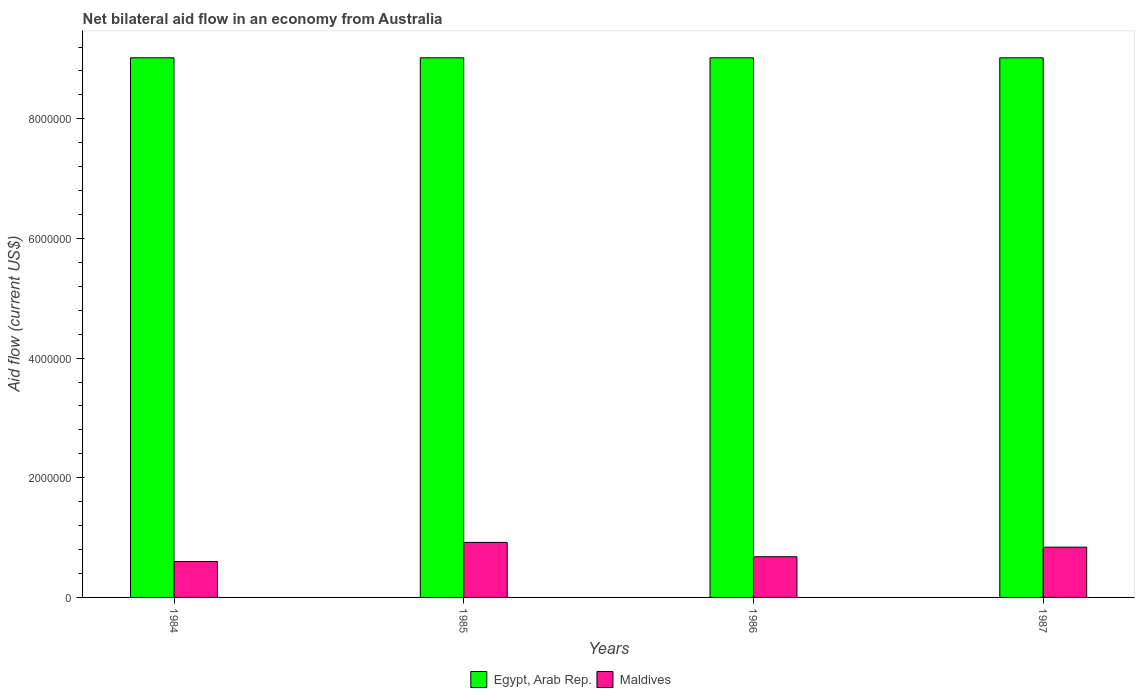How many different coloured bars are there?
Offer a terse response. 2. Are the number of bars per tick equal to the number of legend labels?
Offer a terse response. Yes. How many bars are there on the 4th tick from the right?
Offer a terse response. 2. What is the label of the 4th group of bars from the left?
Provide a short and direct response. 1987. In how many cases, is the number of bars for a given year not equal to the number of legend labels?
Make the answer very short. 0. What is the net bilateral aid flow in Maldives in 1985?
Provide a short and direct response. 9.20e+05. Across all years, what is the maximum net bilateral aid flow in Maldives?
Give a very brief answer. 9.20e+05. What is the total net bilateral aid flow in Maldives in the graph?
Your answer should be very brief. 3.04e+06. What is the difference between the net bilateral aid flow in Maldives in 1987 and the net bilateral aid flow in Egypt, Arab Rep. in 1984?
Offer a terse response. -8.18e+06. What is the average net bilateral aid flow in Maldives per year?
Your answer should be compact. 7.60e+05. In the year 1985, what is the difference between the net bilateral aid flow in Maldives and net bilateral aid flow in Egypt, Arab Rep.?
Your answer should be compact. -8.10e+06. In how many years, is the net bilateral aid flow in Maldives greater than 8400000 US$?
Provide a succinct answer. 0. What is the difference between the highest and the second highest net bilateral aid flow in Maldives?
Keep it short and to the point. 8.00e+04. In how many years, is the net bilateral aid flow in Maldives greater than the average net bilateral aid flow in Maldives taken over all years?
Provide a succinct answer. 2. Is the sum of the net bilateral aid flow in Maldives in 1984 and 1986 greater than the maximum net bilateral aid flow in Egypt, Arab Rep. across all years?
Offer a terse response. No. What does the 2nd bar from the left in 1987 represents?
Your answer should be compact. Maldives. What does the 2nd bar from the right in 1985 represents?
Keep it short and to the point. Egypt, Arab Rep. Are all the bars in the graph horizontal?
Make the answer very short. No. How many years are there in the graph?
Offer a very short reply. 4. Does the graph contain any zero values?
Give a very brief answer. No. What is the title of the graph?
Your answer should be compact. Net bilateral aid flow in an economy from Australia. Does "Hungary" appear as one of the legend labels in the graph?
Ensure brevity in your answer.  No. What is the label or title of the X-axis?
Make the answer very short. Years. What is the Aid flow (current US$) of Egypt, Arab Rep. in 1984?
Your answer should be very brief. 9.02e+06. What is the Aid flow (current US$) in Egypt, Arab Rep. in 1985?
Provide a succinct answer. 9.02e+06. What is the Aid flow (current US$) in Maldives in 1985?
Ensure brevity in your answer.  9.20e+05. What is the Aid flow (current US$) in Egypt, Arab Rep. in 1986?
Offer a very short reply. 9.02e+06. What is the Aid flow (current US$) of Maldives in 1986?
Keep it short and to the point. 6.80e+05. What is the Aid flow (current US$) of Egypt, Arab Rep. in 1987?
Provide a succinct answer. 9.02e+06. What is the Aid flow (current US$) in Maldives in 1987?
Provide a succinct answer. 8.40e+05. Across all years, what is the maximum Aid flow (current US$) in Egypt, Arab Rep.?
Offer a very short reply. 9.02e+06. Across all years, what is the maximum Aid flow (current US$) of Maldives?
Provide a short and direct response. 9.20e+05. Across all years, what is the minimum Aid flow (current US$) in Egypt, Arab Rep.?
Give a very brief answer. 9.02e+06. What is the total Aid flow (current US$) of Egypt, Arab Rep. in the graph?
Provide a short and direct response. 3.61e+07. What is the total Aid flow (current US$) in Maldives in the graph?
Ensure brevity in your answer.  3.04e+06. What is the difference between the Aid flow (current US$) in Egypt, Arab Rep. in 1984 and that in 1985?
Ensure brevity in your answer.  0. What is the difference between the Aid flow (current US$) of Maldives in 1984 and that in 1985?
Offer a terse response. -3.20e+05. What is the difference between the Aid flow (current US$) of Maldives in 1984 and that in 1986?
Your response must be concise. -8.00e+04. What is the difference between the Aid flow (current US$) of Maldives in 1985 and that in 1987?
Provide a short and direct response. 8.00e+04. What is the difference between the Aid flow (current US$) of Egypt, Arab Rep. in 1984 and the Aid flow (current US$) of Maldives in 1985?
Your answer should be compact. 8.10e+06. What is the difference between the Aid flow (current US$) in Egypt, Arab Rep. in 1984 and the Aid flow (current US$) in Maldives in 1986?
Offer a terse response. 8.34e+06. What is the difference between the Aid flow (current US$) of Egypt, Arab Rep. in 1984 and the Aid flow (current US$) of Maldives in 1987?
Offer a terse response. 8.18e+06. What is the difference between the Aid flow (current US$) of Egypt, Arab Rep. in 1985 and the Aid flow (current US$) of Maldives in 1986?
Your response must be concise. 8.34e+06. What is the difference between the Aid flow (current US$) of Egypt, Arab Rep. in 1985 and the Aid flow (current US$) of Maldives in 1987?
Give a very brief answer. 8.18e+06. What is the difference between the Aid flow (current US$) of Egypt, Arab Rep. in 1986 and the Aid flow (current US$) of Maldives in 1987?
Ensure brevity in your answer.  8.18e+06. What is the average Aid flow (current US$) in Egypt, Arab Rep. per year?
Provide a succinct answer. 9.02e+06. What is the average Aid flow (current US$) of Maldives per year?
Provide a succinct answer. 7.60e+05. In the year 1984, what is the difference between the Aid flow (current US$) of Egypt, Arab Rep. and Aid flow (current US$) of Maldives?
Make the answer very short. 8.42e+06. In the year 1985, what is the difference between the Aid flow (current US$) in Egypt, Arab Rep. and Aid flow (current US$) in Maldives?
Your response must be concise. 8.10e+06. In the year 1986, what is the difference between the Aid flow (current US$) of Egypt, Arab Rep. and Aid flow (current US$) of Maldives?
Your answer should be compact. 8.34e+06. In the year 1987, what is the difference between the Aid flow (current US$) in Egypt, Arab Rep. and Aid flow (current US$) in Maldives?
Offer a very short reply. 8.18e+06. What is the ratio of the Aid flow (current US$) of Maldives in 1984 to that in 1985?
Your response must be concise. 0.65. What is the ratio of the Aid flow (current US$) in Maldives in 1984 to that in 1986?
Provide a short and direct response. 0.88. What is the ratio of the Aid flow (current US$) of Egypt, Arab Rep. in 1984 to that in 1987?
Provide a succinct answer. 1. What is the ratio of the Aid flow (current US$) in Maldives in 1984 to that in 1987?
Make the answer very short. 0.71. What is the ratio of the Aid flow (current US$) of Maldives in 1985 to that in 1986?
Provide a succinct answer. 1.35. What is the ratio of the Aid flow (current US$) in Maldives in 1985 to that in 1987?
Provide a short and direct response. 1.1. What is the ratio of the Aid flow (current US$) in Maldives in 1986 to that in 1987?
Make the answer very short. 0.81. What is the difference between the highest and the second highest Aid flow (current US$) of Egypt, Arab Rep.?
Offer a very short reply. 0. 